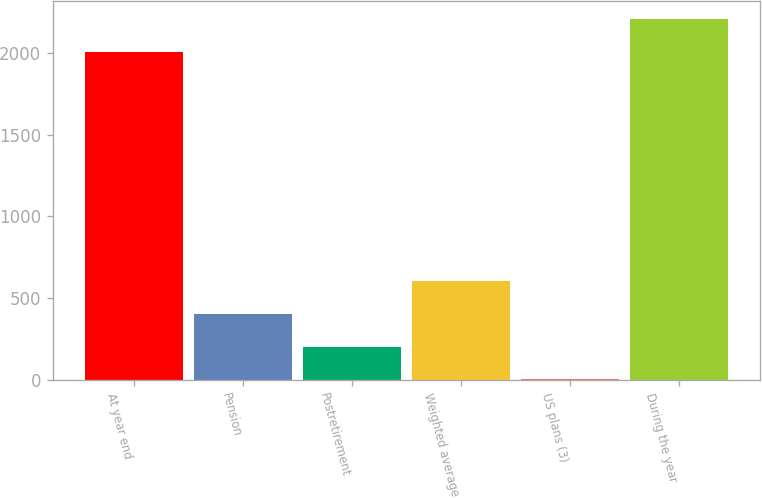Convert chart. <chart><loc_0><loc_0><loc_500><loc_500><bar_chart><fcel>At year end<fcel>Pension<fcel>Postretirement<fcel>Weighted average<fcel>US plans (3)<fcel>During the year<nl><fcel>2007<fcel>403.8<fcel>203.4<fcel>604.2<fcel>3<fcel>2207.4<nl></chart> 